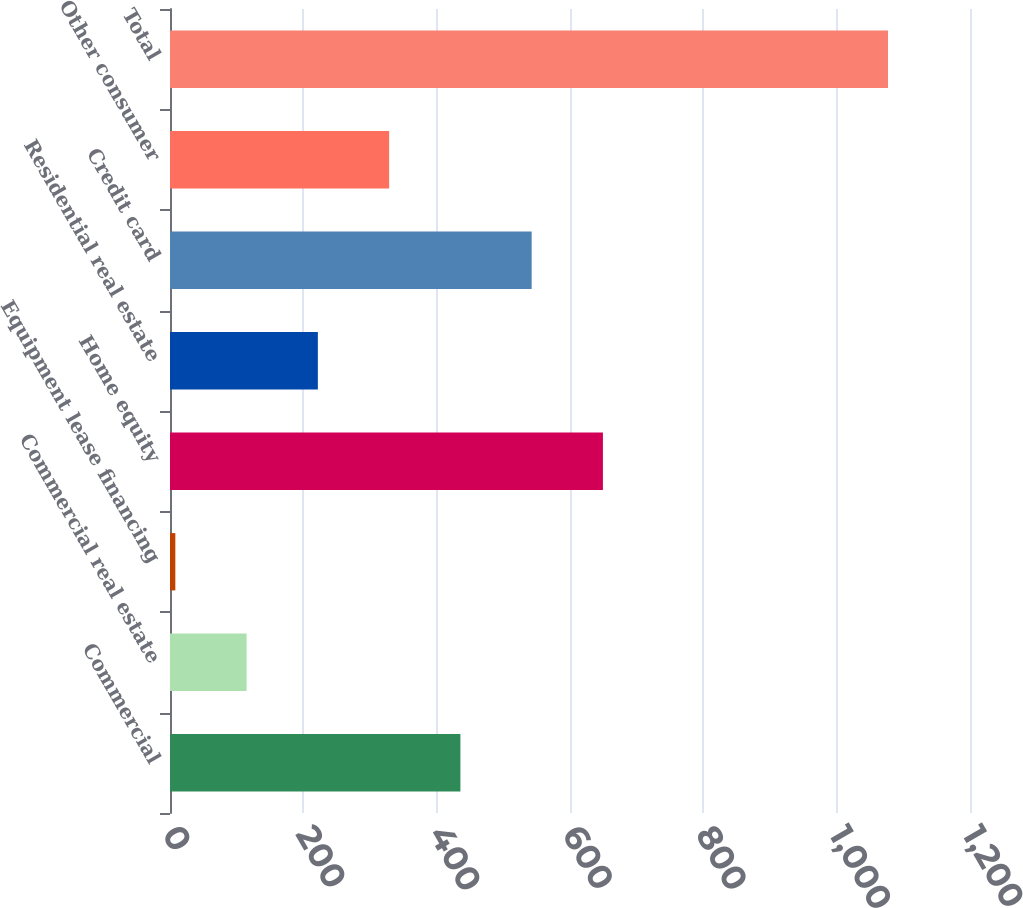Convert chart. <chart><loc_0><loc_0><loc_500><loc_500><bar_chart><fcel>Commercial<fcel>Commercial real estate<fcel>Equipment lease financing<fcel>Home equity<fcel>Residential real estate<fcel>Credit card<fcel>Other consumer<fcel>Total<nl><fcel>435.6<fcel>114.9<fcel>8<fcel>649.4<fcel>221.8<fcel>542.5<fcel>328.7<fcel>1077<nl></chart> 